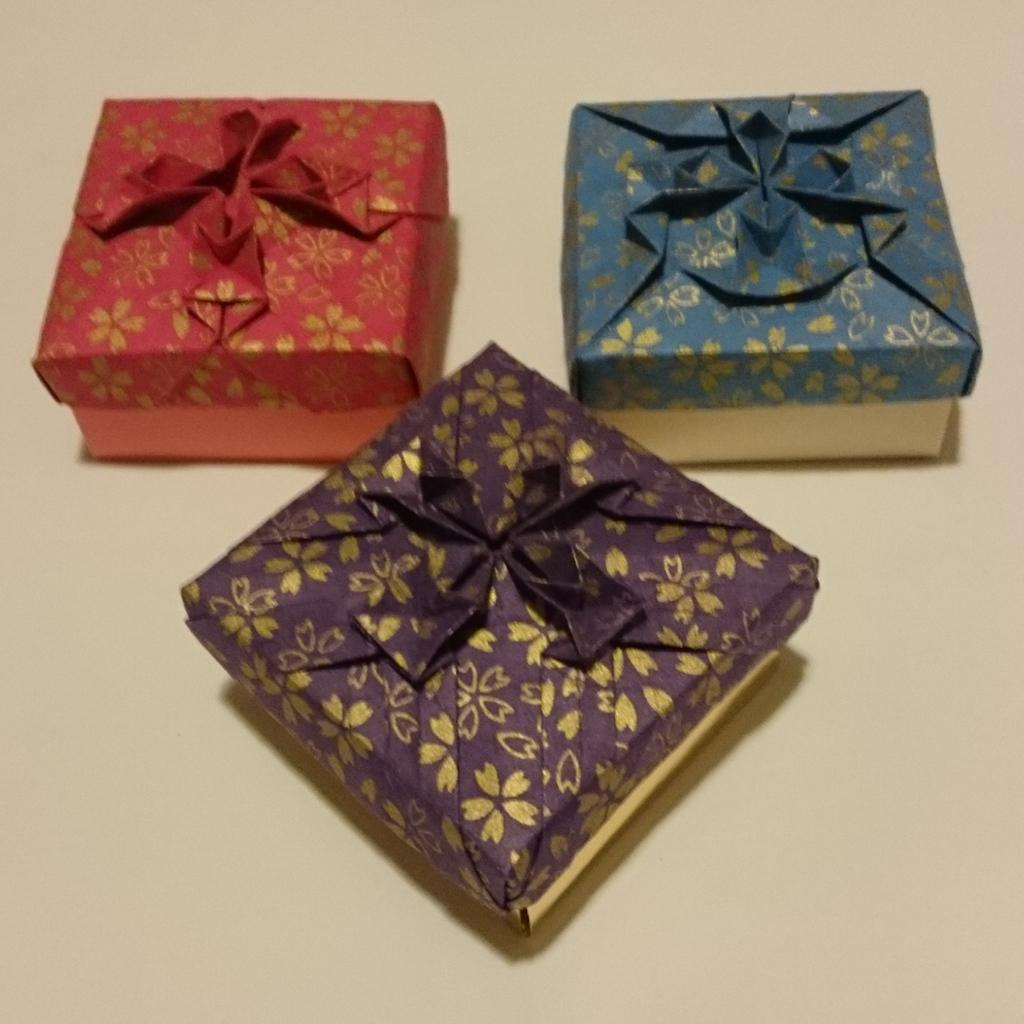How many gift packs are visible in the image? There are three gift packs in the image. What can be observed about the colors of the gift packs? The gift packs are of different colors. Can you identify the color of one of the gift packs? One gift pack is red. Can you identify the color of another gift pack? One gift pack is blue. Can you identify the color of the third gift pack? One gift pack is violet. What type of pan is being used to cook a meal in the image? There is no pan or cooking activity present in the image; it features gift packs of different colors. Can you describe the family members who are present in the image? There are no family members or people present in the image; it features gift packs of different colors. 